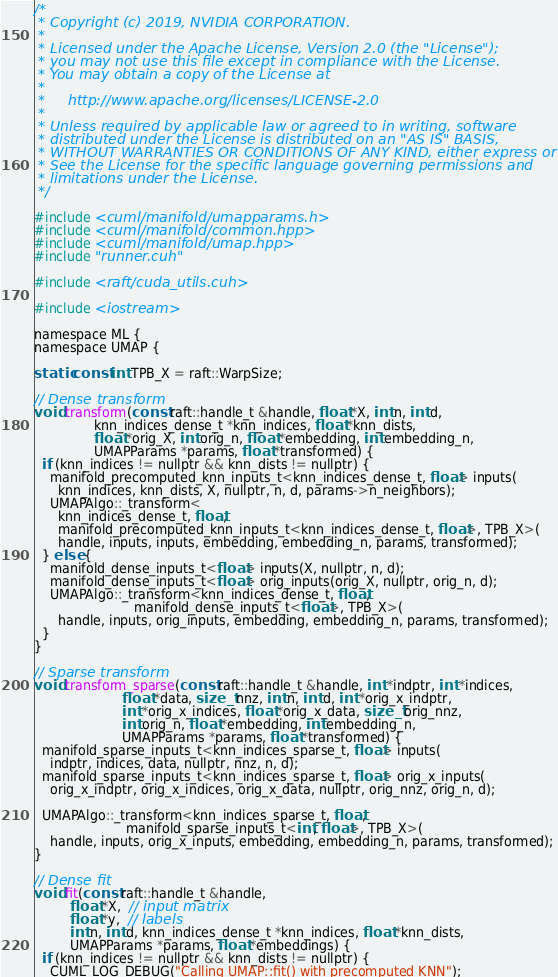Convert code to text. <code><loc_0><loc_0><loc_500><loc_500><_Cuda_>/*
 * Copyright (c) 2019, NVIDIA CORPORATION.
 *
 * Licensed under the Apache License, Version 2.0 (the "License");
 * you may not use this file except in compliance with the License.
 * You may obtain a copy of the License at
 *
 *     http://www.apache.org/licenses/LICENSE-2.0
 *
 * Unless required by applicable law or agreed to in writing, software
 * distributed under the License is distributed on an "AS IS" BASIS,
 * WITHOUT WARRANTIES OR CONDITIONS OF ANY KIND, either express or implied.
 * See the License for the specific language governing permissions and
 * limitations under the License.
 */

#include <cuml/manifold/umapparams.h>
#include <cuml/manifold/common.hpp>
#include <cuml/manifold/umap.hpp>
#include "runner.cuh"

#include <raft/cuda_utils.cuh>

#include <iostream>

namespace ML {
namespace UMAP {

static const int TPB_X = raft::WarpSize;

// Dense transform
void transform(const raft::handle_t &handle, float *X, int n, int d,
               knn_indices_dense_t *knn_indices, float *knn_dists,
               float *orig_X, int orig_n, float *embedding, int embedding_n,
               UMAPParams *params, float *transformed) {
  if (knn_indices != nullptr && knn_dists != nullptr) {
    manifold_precomputed_knn_inputs_t<knn_indices_dense_t, float> inputs(
      knn_indices, knn_dists, X, nullptr, n, d, params->n_neighbors);
    UMAPAlgo::_transform<
      knn_indices_dense_t, float,
      manifold_precomputed_knn_inputs_t<knn_indices_dense_t, float>, TPB_X>(
      handle, inputs, inputs, embedding, embedding_n, params, transformed);
  } else {
    manifold_dense_inputs_t<float> inputs(X, nullptr, n, d);
    manifold_dense_inputs_t<float> orig_inputs(orig_X, nullptr, orig_n, d);
    UMAPAlgo::_transform<knn_indices_dense_t, float,
                         manifold_dense_inputs_t<float>, TPB_X>(
      handle, inputs, orig_inputs, embedding, embedding_n, params, transformed);
  }
}

// Sparse transform
void transform_sparse(const raft::handle_t &handle, int *indptr, int *indices,
                      float *data, size_t nnz, int n, int d, int *orig_x_indptr,
                      int *orig_x_indices, float *orig_x_data, size_t orig_nnz,
                      int orig_n, float *embedding, int embedding_n,
                      UMAPParams *params, float *transformed) {
  manifold_sparse_inputs_t<knn_indices_sparse_t, float> inputs(
    indptr, indices, data, nullptr, nnz, n, d);
  manifold_sparse_inputs_t<knn_indices_sparse_t, float> orig_x_inputs(
    orig_x_indptr, orig_x_indices, orig_x_data, nullptr, orig_nnz, orig_n, d);

  UMAPAlgo::_transform<knn_indices_sparse_t, float,
                       manifold_sparse_inputs_t<int, float>, TPB_X>(
    handle, inputs, orig_x_inputs, embedding, embedding_n, params, transformed);
}

// Dense fit
void fit(const raft::handle_t &handle,
         float *X,  // input matrix
         float *y,  // labels
         int n, int d, knn_indices_dense_t *knn_indices, float *knn_dists,
         UMAPParams *params, float *embeddings) {
  if (knn_indices != nullptr && knn_dists != nullptr) {
    CUML_LOG_DEBUG("Calling UMAP::fit() with precomputed KNN");
</code> 